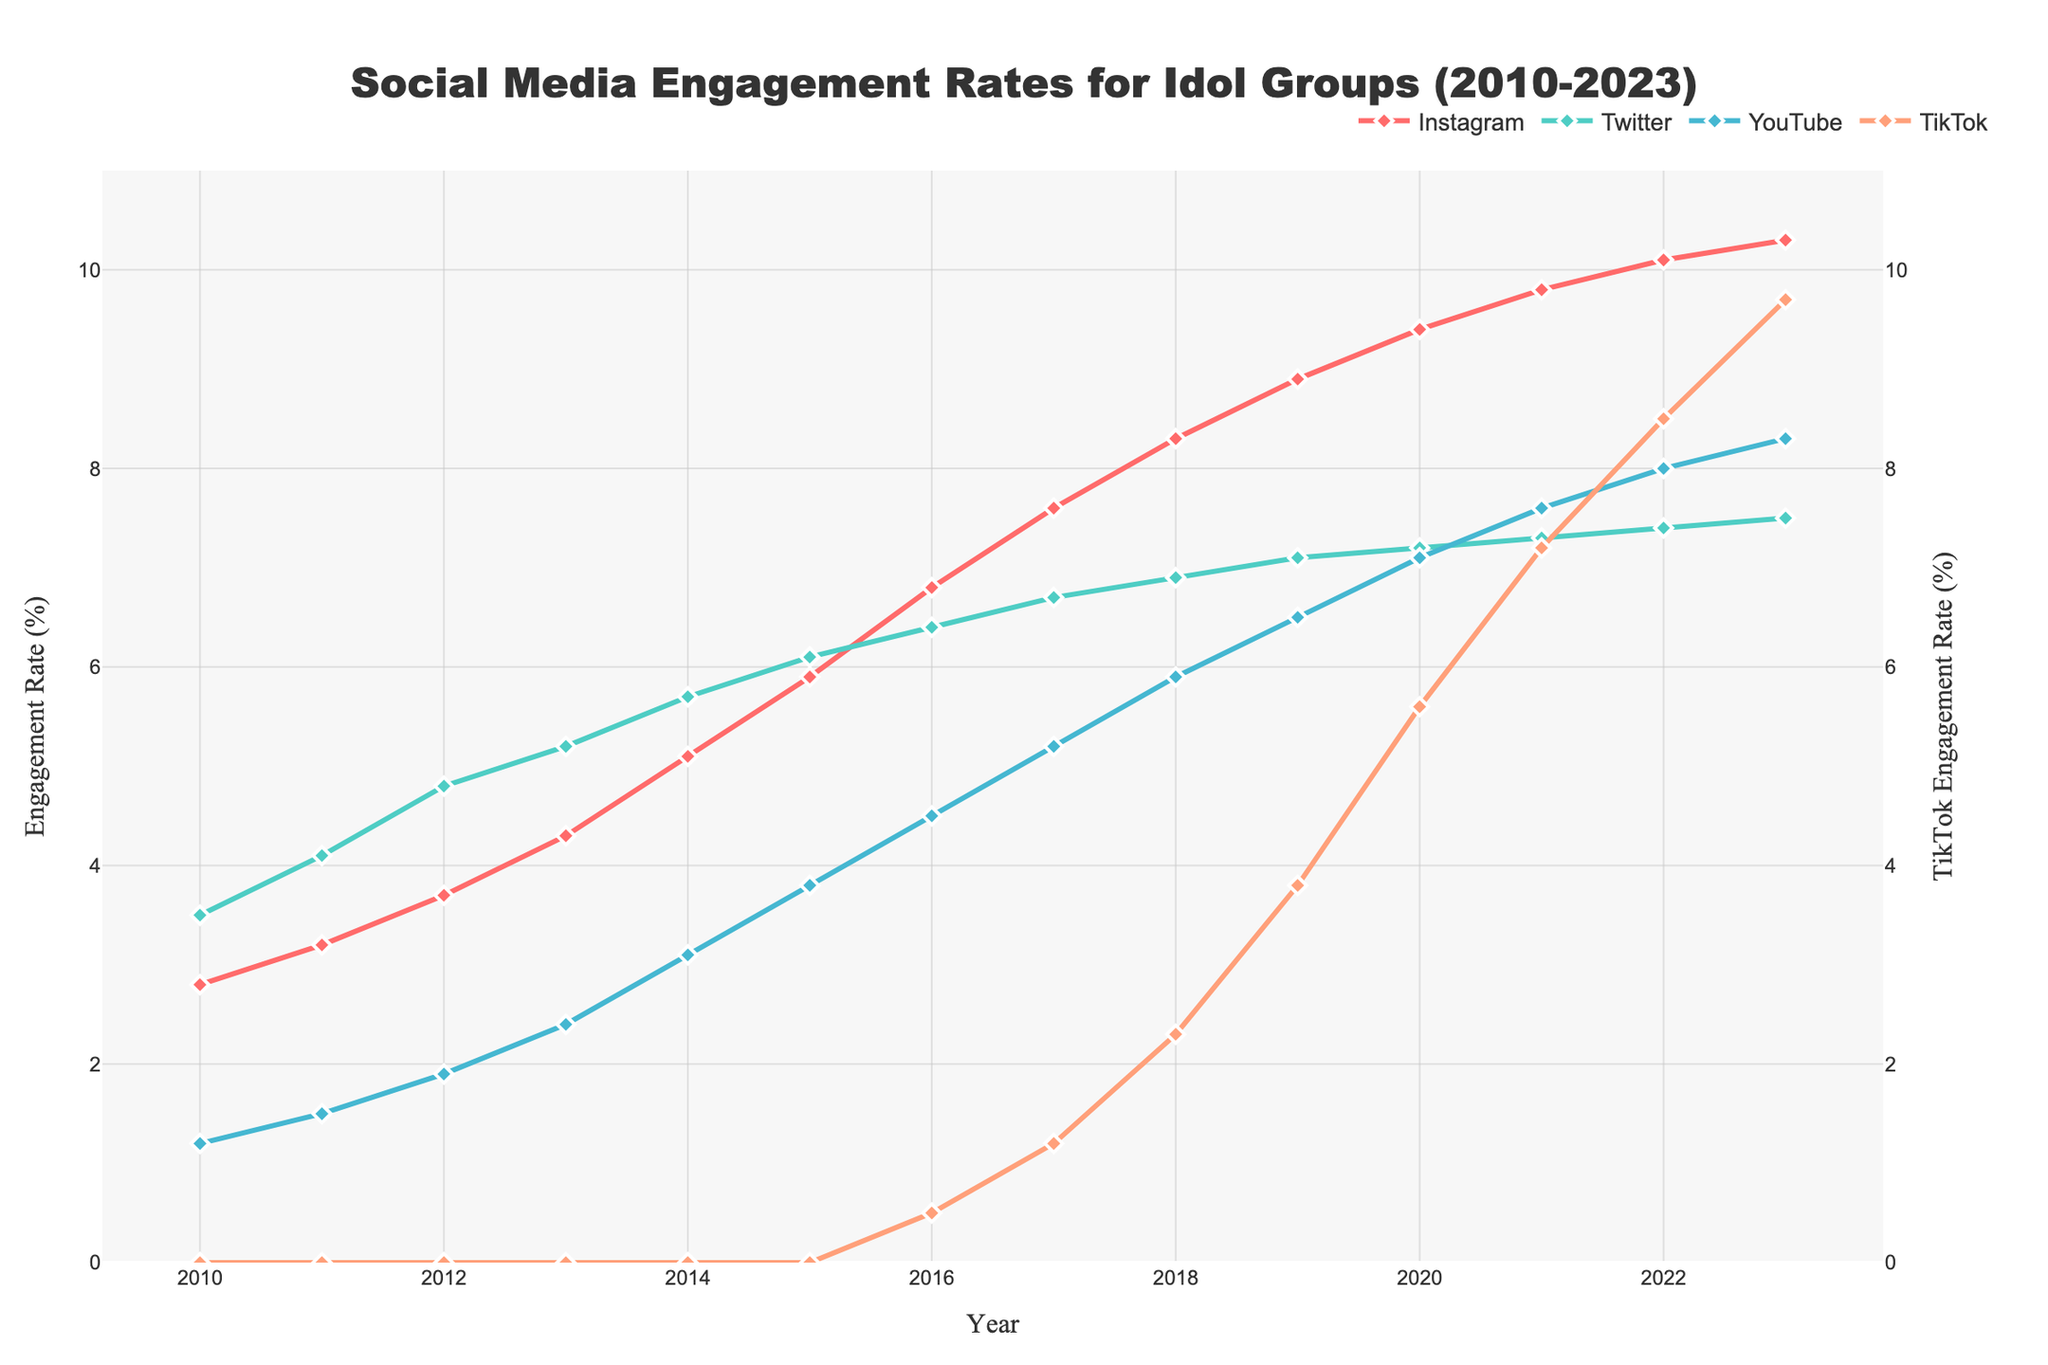What was the engagement rate on Instagram in 2015? To find the answer, locate the intersection of the "Instagram" line and the year 2015 on the x-axis. The value at this intersection represents the engagement rate.
Answer: 5.9% Which platform had the highest engagement rate in 2016? Examine the engagement rates for all platforms in the year 2016. The platform with the highest numerical value is the one with the highest engagement rate.
Answer: Instagram How did the engagement rate on Twitter change from 2010 to 2023? To find the change, subtract the engagement rate on Twitter in 2010 from the rate in 2023. This shows whether the rate increased or decreased over this period.
Answer: Increased by 4.0% Which year did TikTok start appearing in the data, and what was its initial engagement rate? Identify the first year TikTok data appears on the chart. The engagement rate for TikTok in that year is its initial rate.
Answer: 2016, 0.5% What is the average engagement rate of YouTube from 2010 to 2023? Add the YouTube engagement rates from 2010 to 2023, then divide the sum by the number of years (14) to get the average engagement rate.
Answer: 4.87% Between which consecutive years did Instagram see the largest increase in engagement rate? For each consecutive year pair, calculate the difference in Instagram's engagement rates. The largest difference indicates the largest increase.
Answer: 2013 to 2014 Which platform showed the most consistent growth trend over the years? Evaluate the trend lines of all platforms. Consistency in growth can be indicated by a steady upward slope with few fluctuations.
Answer: Instagram What was the combined engagement rate of all platforms in 2020? Sum the engagement rates of Instagram, Twitter, YouTube, and TikTok for the year 2020. This provides the combined engagement rate across all platforms.
Answer: 29.3% How did TikTok's engagement rate in 2023 compare to its rate in 2017? Subtract TikTok’s engagement rate in 2017 from its rate in 2023 to find the difference. This will show how much the rate has increased.
Answer: Increased by 8.5% In which year did YouTube's engagement rate surpass 5%? Examine YouTube's engagement rates year by year until you find the first year where the rate exceeds 5%.
Answer: 2017 